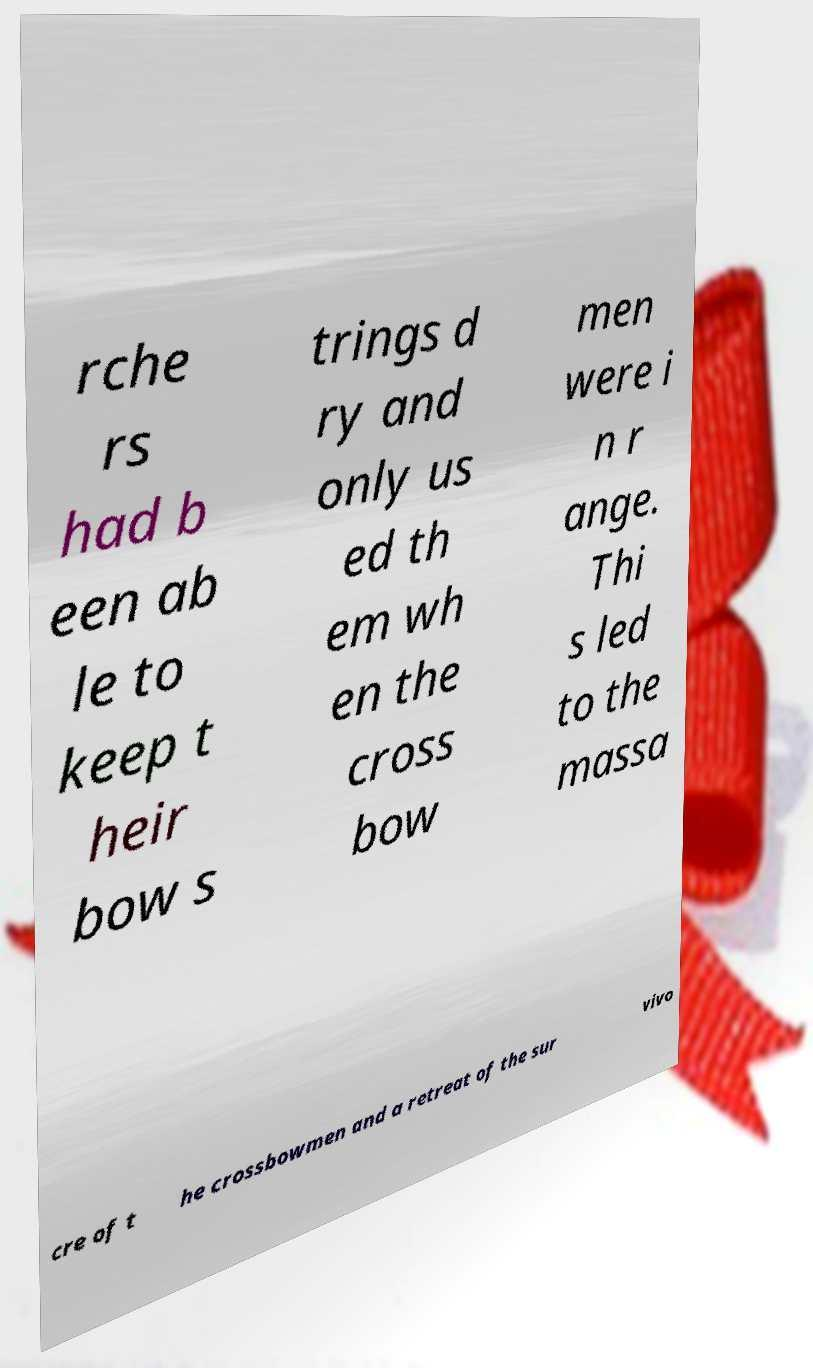There's text embedded in this image that I need extracted. Can you transcribe it verbatim? rche rs had b een ab le to keep t heir bow s trings d ry and only us ed th em wh en the cross bow men were i n r ange. Thi s led to the massa cre of t he crossbowmen and a retreat of the sur vivo 